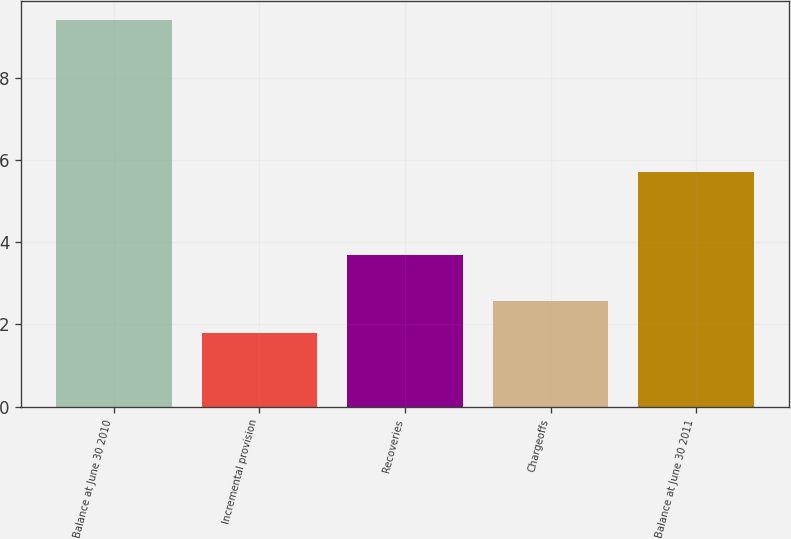Convert chart. <chart><loc_0><loc_0><loc_500><loc_500><bar_chart><fcel>Balance at June 30 2010<fcel>Incremental provision<fcel>Recoveries<fcel>Chargeoffs<fcel>Balance at June 30 2011<nl><fcel>9.4<fcel>1.8<fcel>3.7<fcel>2.56<fcel>5.7<nl></chart> 